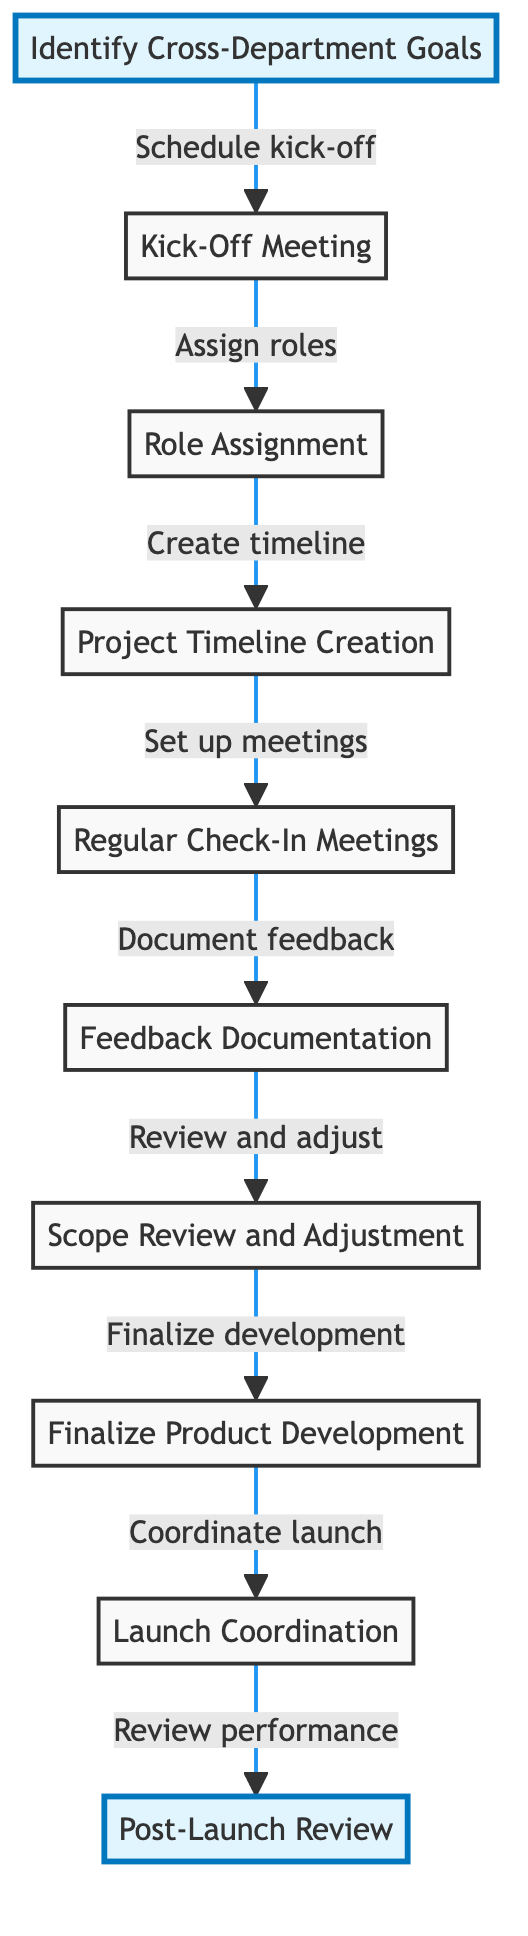What is the first step in the workflow? The first step, according to the diagram, is "Identify Cross-Department Goals." This is where collaboration begins with stakeholders to outline shared objectives.
Answer: Identify Cross-Department Goals How many steps are there in the workflow? By counting the nodes in the diagram, we see there are 10 distinct steps, ranging from "Identify Cross-Department Goals" to "Post-Launch Review."
Answer: 10 What is the next step after "Role Assignment"? The next step following "Role Assignment" is "Project Timeline Creation." This indicates that once roles are assigned, the team will then work on establishing a project timeline.
Answer: Project Timeline Creation What does "Feedback Documentation" lead to? "Feedback Documentation" leads to "Scope Review and Adjustment." This shows that documenting feedback is essential for adjusting the project's goals and making necessary improvements.
Answer: Scope Review and Adjustment How many meetings are scheduled after the project timeline is created? After creating the project timeline, "Regular Check-In Meetings" are scheduled, indicating that these meetings are crucial for assessing progress. There aren’t any specific mentions of additional meetings.
Answer: One What is the purpose of the "Post-Launch Review"? The "Post-Launch Review" serves to analyze product performance and the success of cross-department collaboration, aiming for future improvements based on the analysis.
Answer: Analyze product performance What is the last step before "Launch Coordination"? The last step prior to "Launch Coordination" is "Finalize Product Development." This indicates the process of integrating final feedback and preparing for the actual launch.
Answer: Finalize Product Development In what stage are roles and responsibilities assigned? Roles and responsibilities are assigned during the "Kick-Off Meeting" stage, where all representatives discuss project scope and expectations before moving on to role assignment.
Answer: Kick-Off Meeting Which two departments are involved in "Launch Coordination"? The two departments involved in "Launch Coordination" are Marketing and Sales, as indicated by the collaboration required for product launch strategies.
Answer: Marketing and Sales What is the focus of "Scope Review and Adjustment"? The focus of "Scope Review and Adjustment" is to evaluate project goals against progress and feedback, ensuring that adjustments are made as necessary to stay aligned with objectives.
Answer: Evaluate project goals 